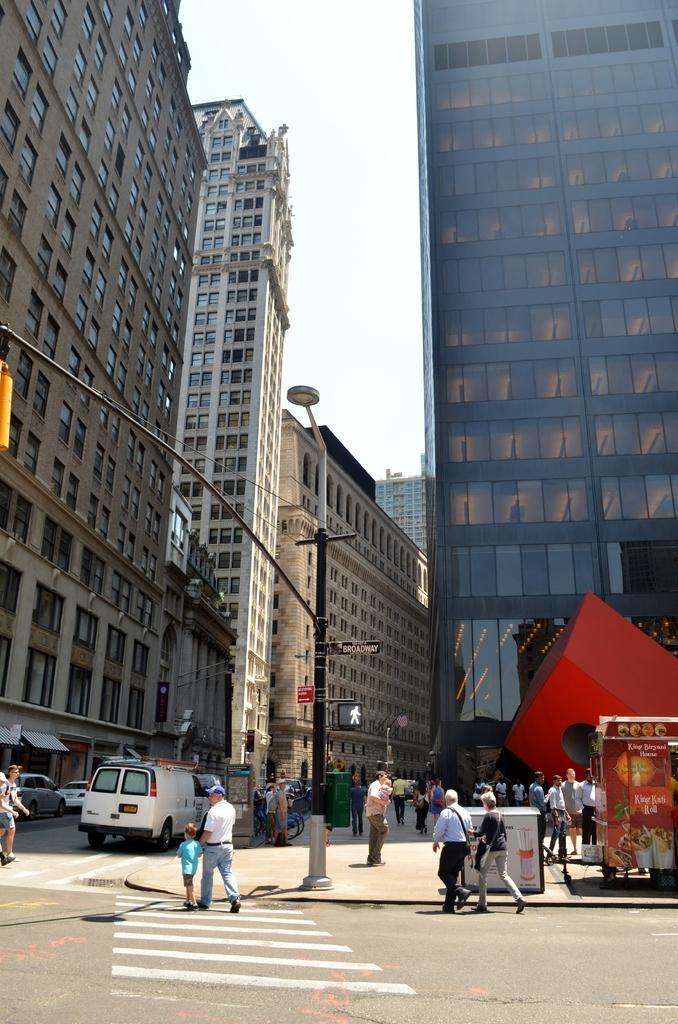Please provide a concise description of this image. In this image we can see people, vehicles, pole, light, boards, road, and buildings. In the background there is sky. 